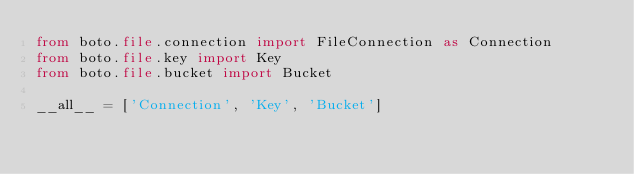Convert code to text. <code><loc_0><loc_0><loc_500><loc_500><_Python_>from boto.file.connection import FileConnection as Connection
from boto.file.key import Key
from boto.file.bucket import Bucket

__all__ = ['Connection', 'Key', 'Bucket']
</code> 